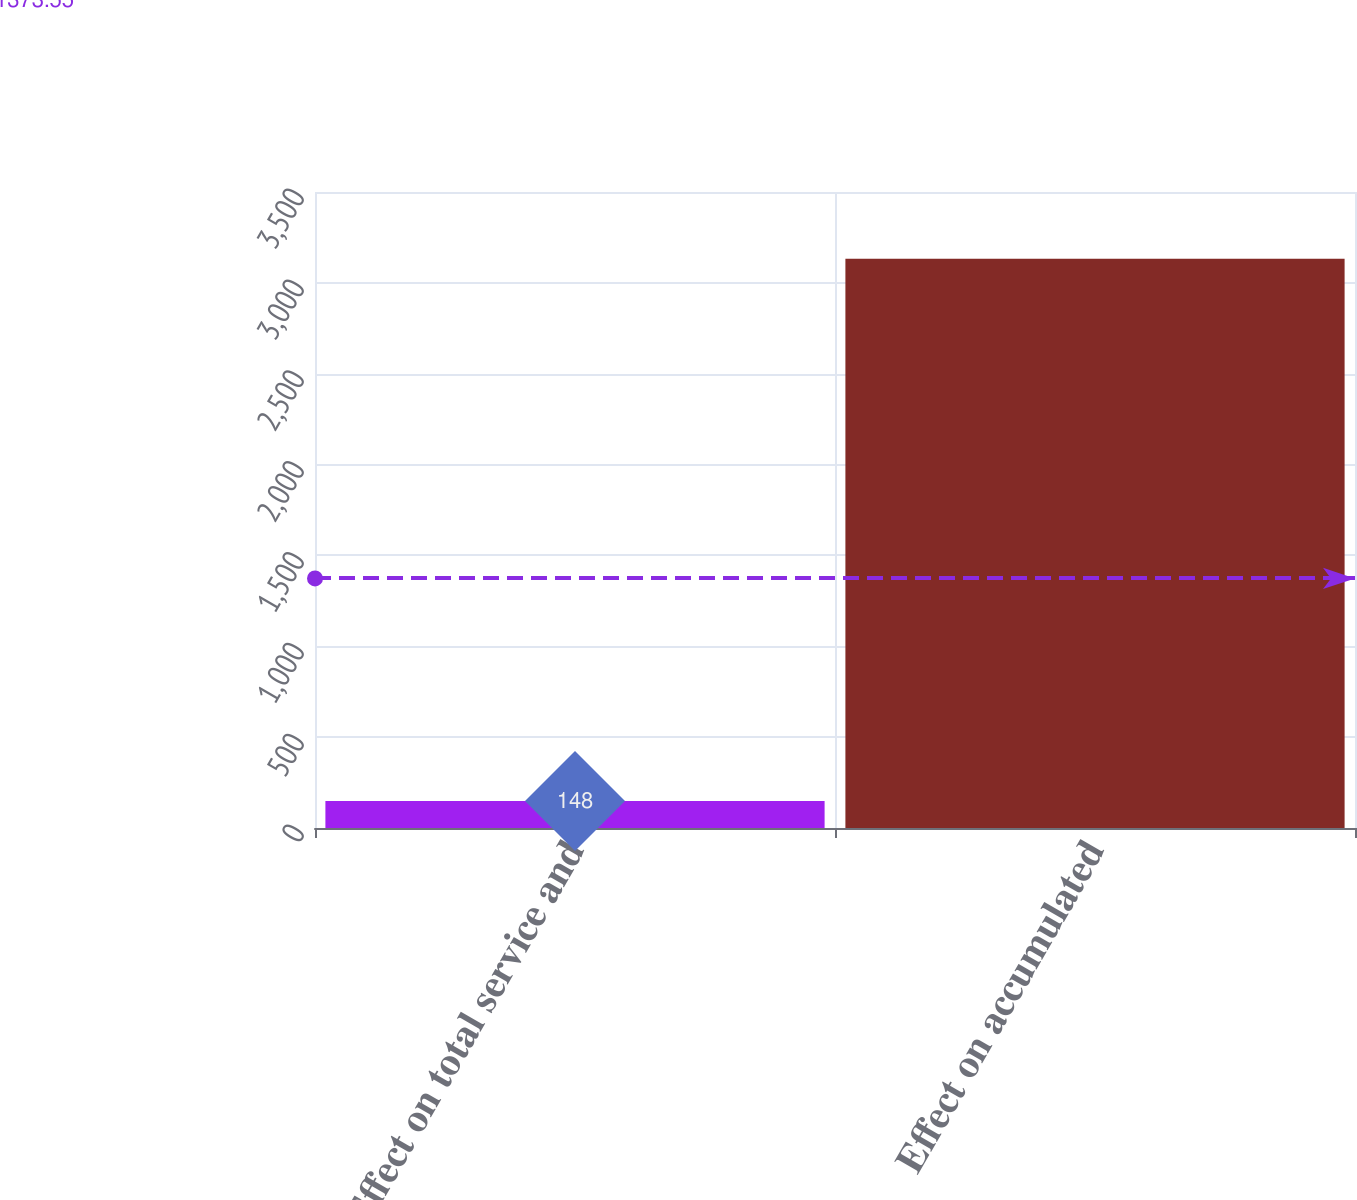Convert chart. <chart><loc_0><loc_0><loc_500><loc_500><bar_chart><fcel>Effect on total service and<fcel>Effect on accumulated<nl><fcel>148<fcel>3133<nl></chart> 